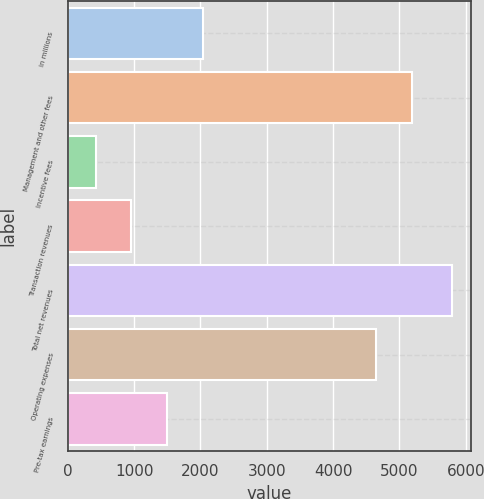Convert chart. <chart><loc_0><loc_0><loc_500><loc_500><bar_chart><fcel>in millions<fcel>Management and other fees<fcel>Incentive fees<fcel>Transaction revenues<fcel>Total net revenues<fcel>Operating expenses<fcel>Pre-tax earnings<nl><fcel>2031.1<fcel>5190.7<fcel>421<fcel>957.7<fcel>5788<fcel>4654<fcel>1494.4<nl></chart> 